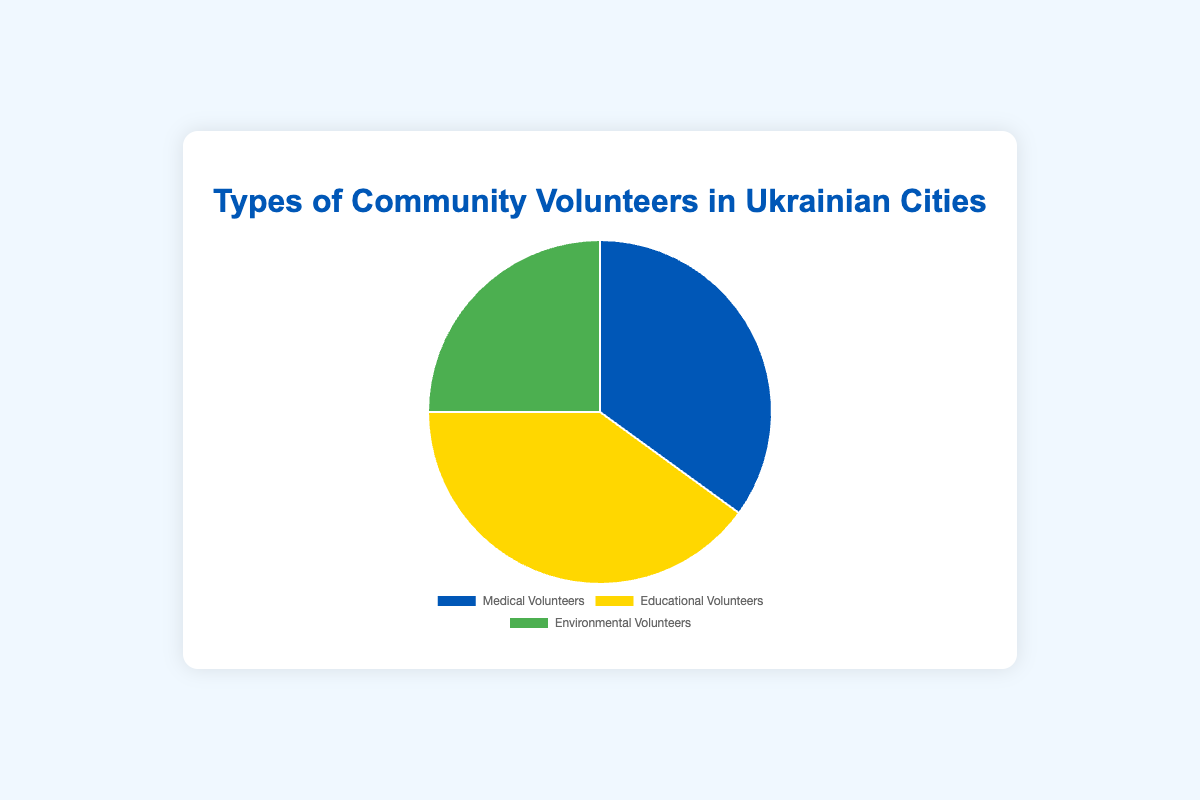What percentage of community volunteers in Ukrainian cities are medical volunteers? The pie chart shows that medical volunteers make up 35% of the total community volunteers.
Answer: 35% Which type of community volunteer has the highest percentage? Comparing the segments of the pie chart, educational volunteers have the largest segment, representing 40% of the total.
Answer: Educational volunteers Which color is used to represent environmental volunteers in the pie chart? The visual attribute for environmental volunteers is green according to the pie chart legend.
Answer: Green How many more percentage points do educational volunteers have compared to environmental volunteers? Educational volunteers are at 40%, and environmental volunteers are at 25%. The difference is 40% - 25% = 15%.
Answer: 15% What is the combined percentage of medical and environmental volunteers? Adding the percentages for medical (35%) and environmental (25%) volunteers gives 35% + 25% = 60%.
Answer: 60% If the total number of volunteers is 2000, how many are medical volunteers? 35% of 2000 volunteers is calculated by 0.35 * 2000 = 700.
Answer: 700 Which type of volunteer is less prevalent than medical volunteers but more prevalent than environmental volunteers? Sorting the percentages, we see medical volunteers are at 35%, educational volunteers at 40%, and environmental volunteers at 25%. Educational volunteers have a higher percentage than medical, and medical has a higher percentage than environmental.
Answer: Medical volunteers What percentage would the pie chart segment for each type of volunteer need to be if environmental volunteers' percentage increased to 30% and the other two decreased equally? Environmental volunteers would be at 30%. Total reduction is 40% - 25% = 5%. This 5% decrease should be divided equally between medical and educational volunteers: 5% / 2 = 2.5%. Therefore, medical volunteers would be 35% - 2.5% = 32.5%, and educational volunteers would be 40% - 2.5% = 37.5%.
Answer: 32.5%, 37.5%, 30% What percent more prevalent are educational volunteers compared to medical volunteers? Educational volunteers are at 40%, and medical volunteers are at 35%. The percentage difference is ((40-35) / 35) * 100 = 14.29%.
Answer: 14.29% What is the average percentage of all three types of community volunteers? The average percentage is calculated by (35% + 40% + 25%) / 3 = 33.33%.
Answer: 33.33% 